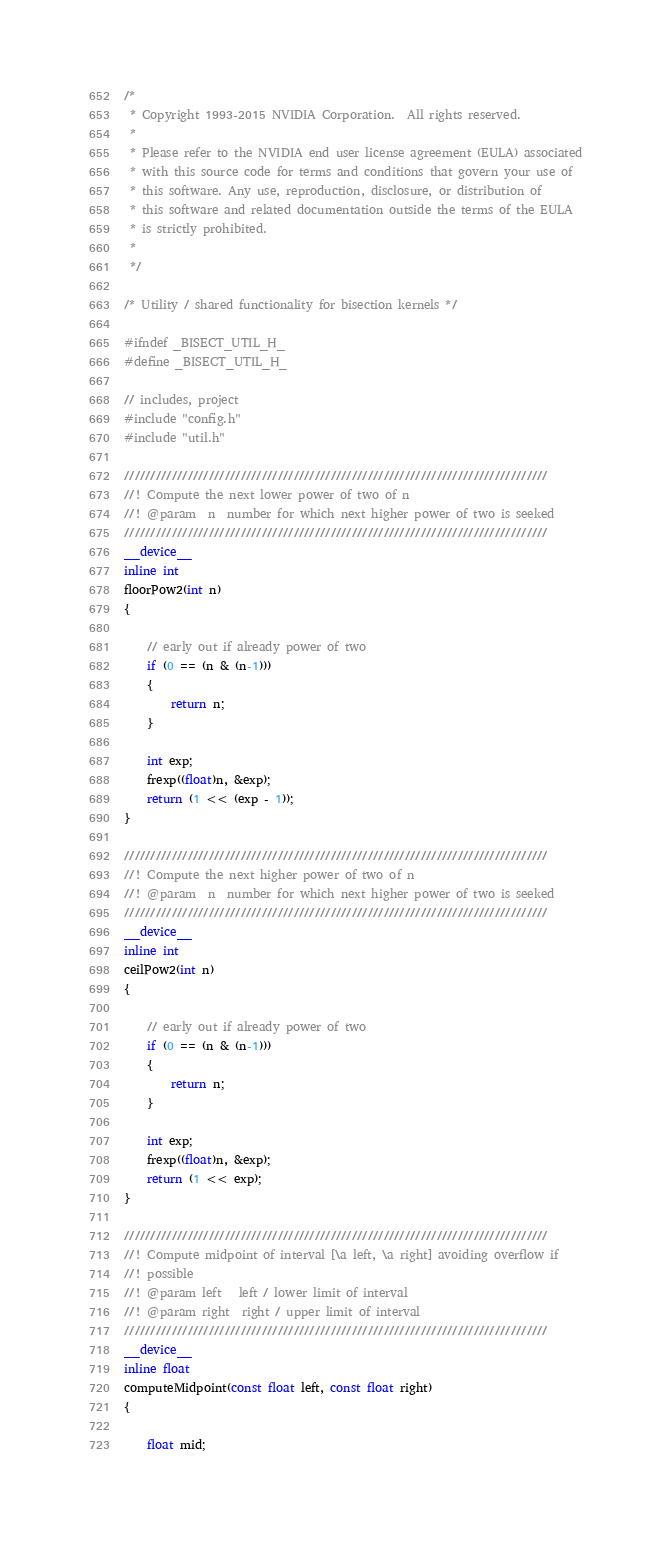<code> <loc_0><loc_0><loc_500><loc_500><_Cuda_>/*
 * Copyright 1993-2015 NVIDIA Corporation.  All rights reserved.
 *
 * Please refer to the NVIDIA end user license agreement (EULA) associated
 * with this source code for terms and conditions that govern your use of
 * this software. Any use, reproduction, disclosure, or distribution of
 * this software and related documentation outside the terms of the EULA
 * is strictly prohibited.
 *
 */

/* Utility / shared functionality for bisection kernels */

#ifndef _BISECT_UTIL_H_
#define _BISECT_UTIL_H_

// includes, project
#include "config.h"
#include "util.h"

////////////////////////////////////////////////////////////////////////////////
//! Compute the next lower power of two of n
//! @param  n  number for which next higher power of two is seeked
////////////////////////////////////////////////////////////////////////////////
__device__
inline int
floorPow2(int n)
{

    // early out if already power of two
    if (0 == (n & (n-1)))
    {
        return n;
    }

    int exp;
    frexp((float)n, &exp);
    return (1 << (exp - 1));
}

////////////////////////////////////////////////////////////////////////////////
//! Compute the next higher power of two of n
//! @param  n  number for which next higher power of two is seeked
////////////////////////////////////////////////////////////////////////////////
__device__
inline int
ceilPow2(int n)
{

    // early out if already power of two
    if (0 == (n & (n-1)))
    {
        return n;
    }

    int exp;
    frexp((float)n, &exp);
    return (1 << exp);
}

////////////////////////////////////////////////////////////////////////////////
//! Compute midpoint of interval [\a left, \a right] avoiding overflow if
//! possible
//! @param left   left / lower limit of interval
//! @param right  right / upper limit of interval
////////////////////////////////////////////////////////////////////////////////
__device__
inline float
computeMidpoint(const float left, const float right)
{

    float mid;
</code> 